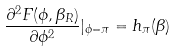<formula> <loc_0><loc_0><loc_500><loc_500>\frac { \partial ^ { 2 } F ( \phi , \beta _ { R } ) } { \partial \phi ^ { 2 } } | _ { \phi = \pi } = h _ { \pi } ( \beta )</formula> 